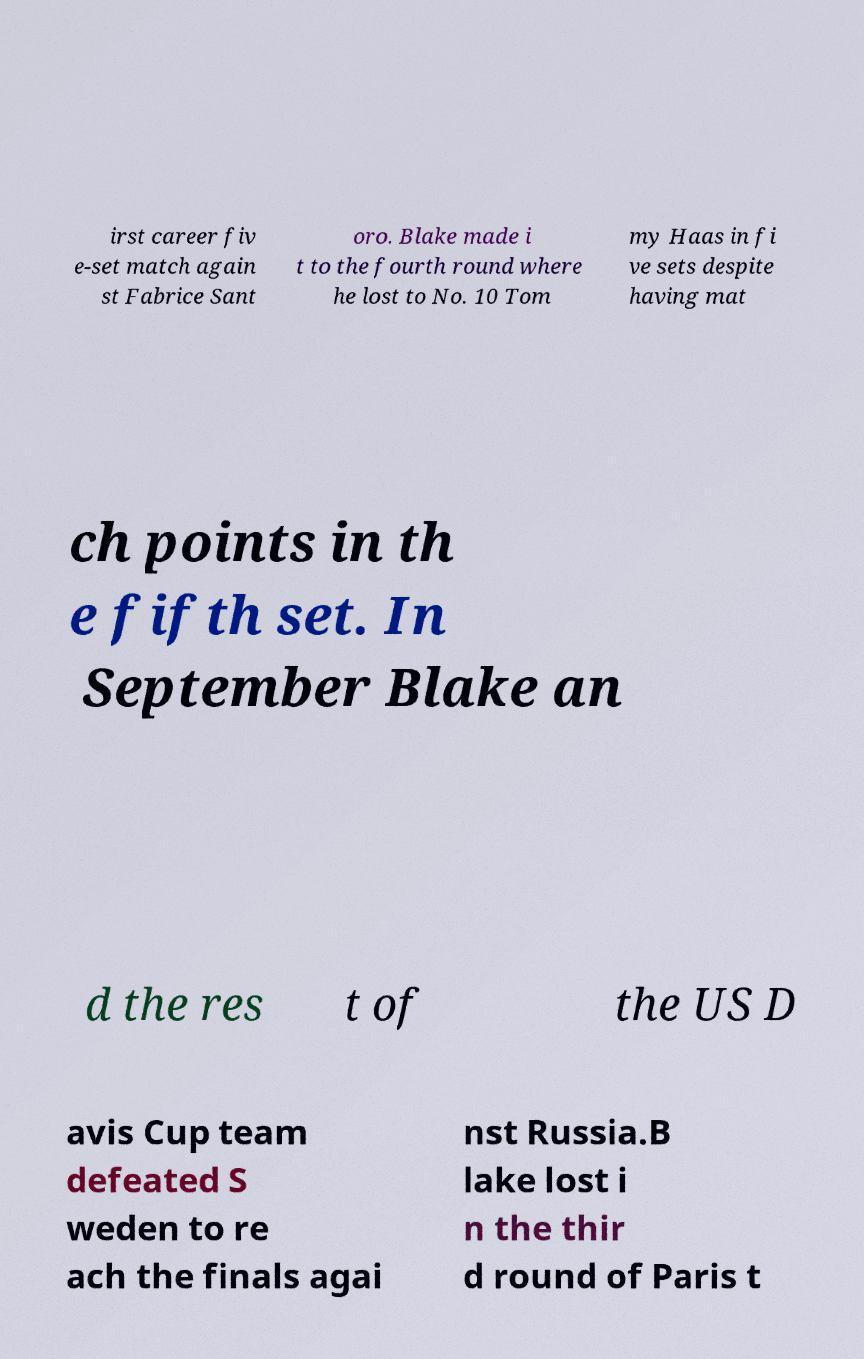Please identify and transcribe the text found in this image. irst career fiv e-set match again st Fabrice Sant oro. Blake made i t to the fourth round where he lost to No. 10 Tom my Haas in fi ve sets despite having mat ch points in th e fifth set. In September Blake an d the res t of the US D avis Cup team defeated S weden to re ach the finals agai nst Russia.B lake lost i n the thir d round of Paris t 